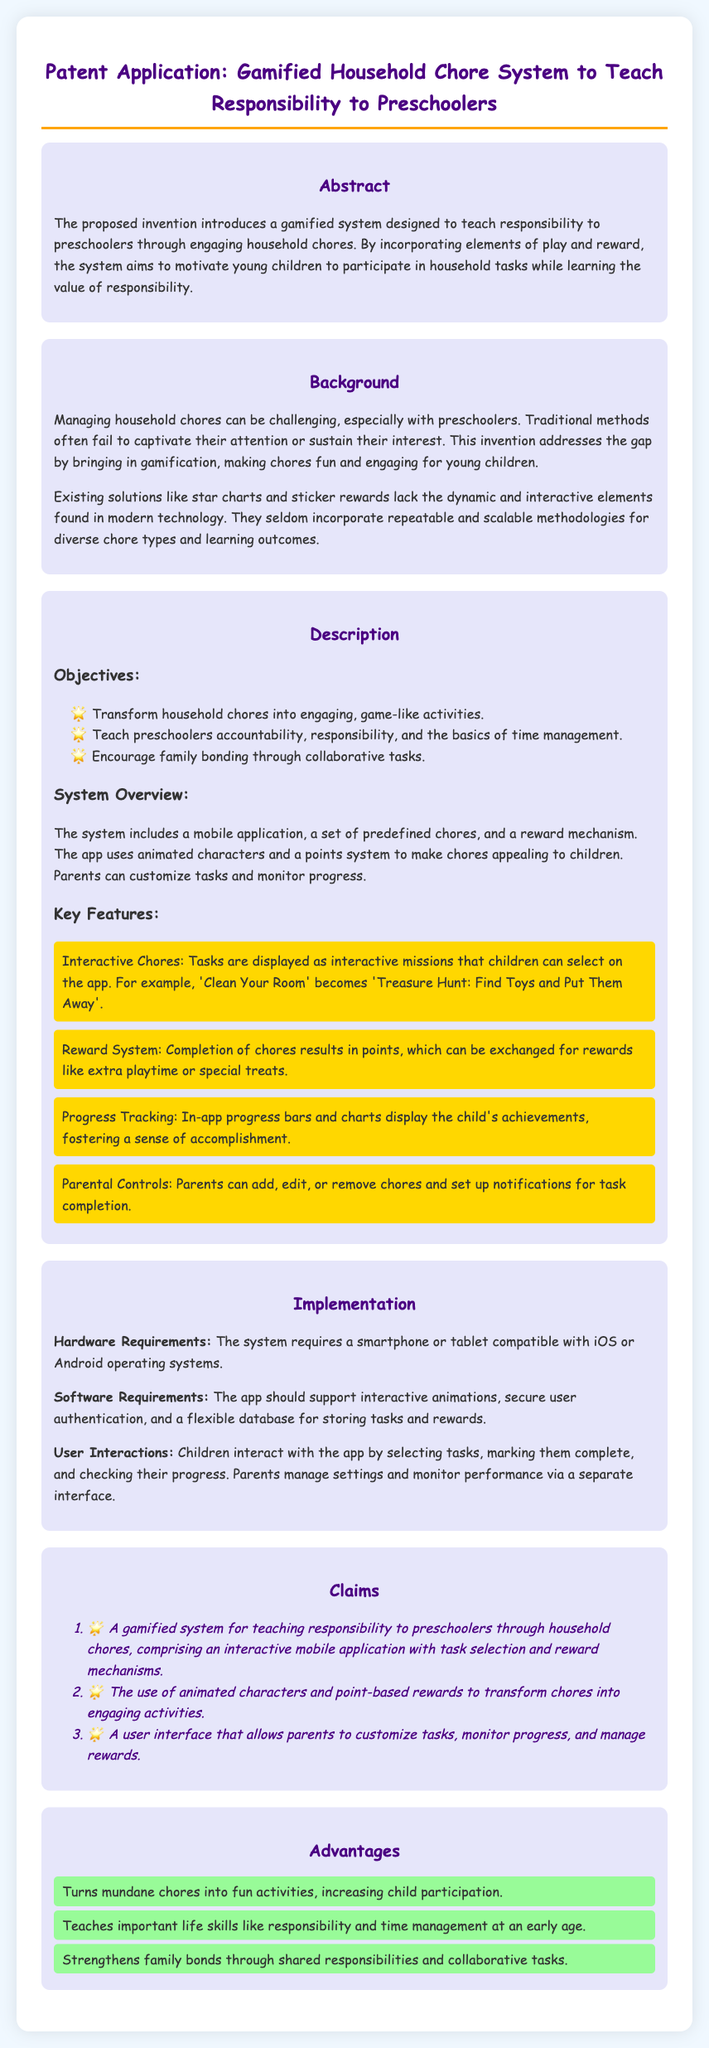What is the title of the patent application? The title provides a summary of the scope of the invention, which is "Gamified Household Chore System to Teach Responsibility to Preschoolers."
Answer: Gamified Household Chore System to Teach Responsibility to Preschoolers What is one key feature of the system? The document lists interactive chores, a reward system, progress tracking, and parental controls as key features.
Answer: Interactive Chores What is the target audience for this system? The application specifically mentions preschoolers as the target audience for teaching responsibility through chores.
Answer: Preschoolers How many claims are made in the patent application? The claims section lists three distinct claims regarding the invention.
Answer: Three What type of devices are required to use the system? The implementation section indicates that the system requires smartphones or tablets.
Answer: Smartphone or tablet What is the primary objective of the system? One of the listed objectives is to transform household chores into engaging, game-like activities for children.
Answer: Engage children What does the reward system allow children to earn? The reward system allows children to earn points that can be exchanged for rewards.
Answer: Points Which aspect of the gamified system promotes family bonding? The objectives highlight that collaborative tasks encourage family bonding through shared responsibilities.
Answer: Collaborative tasks What is the primary advantage of this gamified system? The advantages section states that it increases child participation by making chores fun activities.
Answer: Increases child participation What technology does the app support according to hardware requirements? The document specifies that the app must be compatible with iOS or Android operating systems.
Answer: iOS or Android 